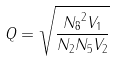Convert formula to latex. <formula><loc_0><loc_0><loc_500><loc_500>Q = \sqrt { \frac { { N _ { 8 } } ^ { 2 } V _ { 1 } } { N _ { 2 } N _ { 5 } V _ { 2 } } }</formula> 